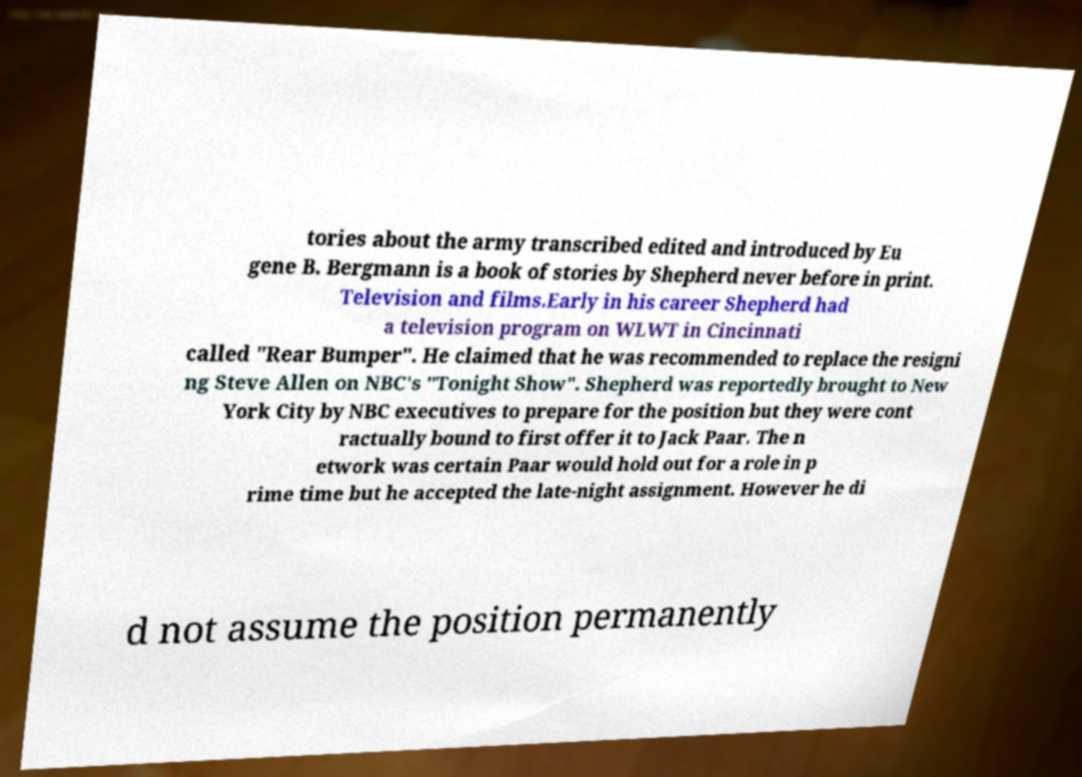Could you extract and type out the text from this image? tories about the army transcribed edited and introduced by Eu gene B. Bergmann is a book of stories by Shepherd never before in print. Television and films.Early in his career Shepherd had a television program on WLWT in Cincinnati called "Rear Bumper". He claimed that he was recommended to replace the resigni ng Steve Allen on NBC's "Tonight Show". Shepherd was reportedly brought to New York City by NBC executives to prepare for the position but they were cont ractually bound to first offer it to Jack Paar. The n etwork was certain Paar would hold out for a role in p rime time but he accepted the late-night assignment. However he di d not assume the position permanently 